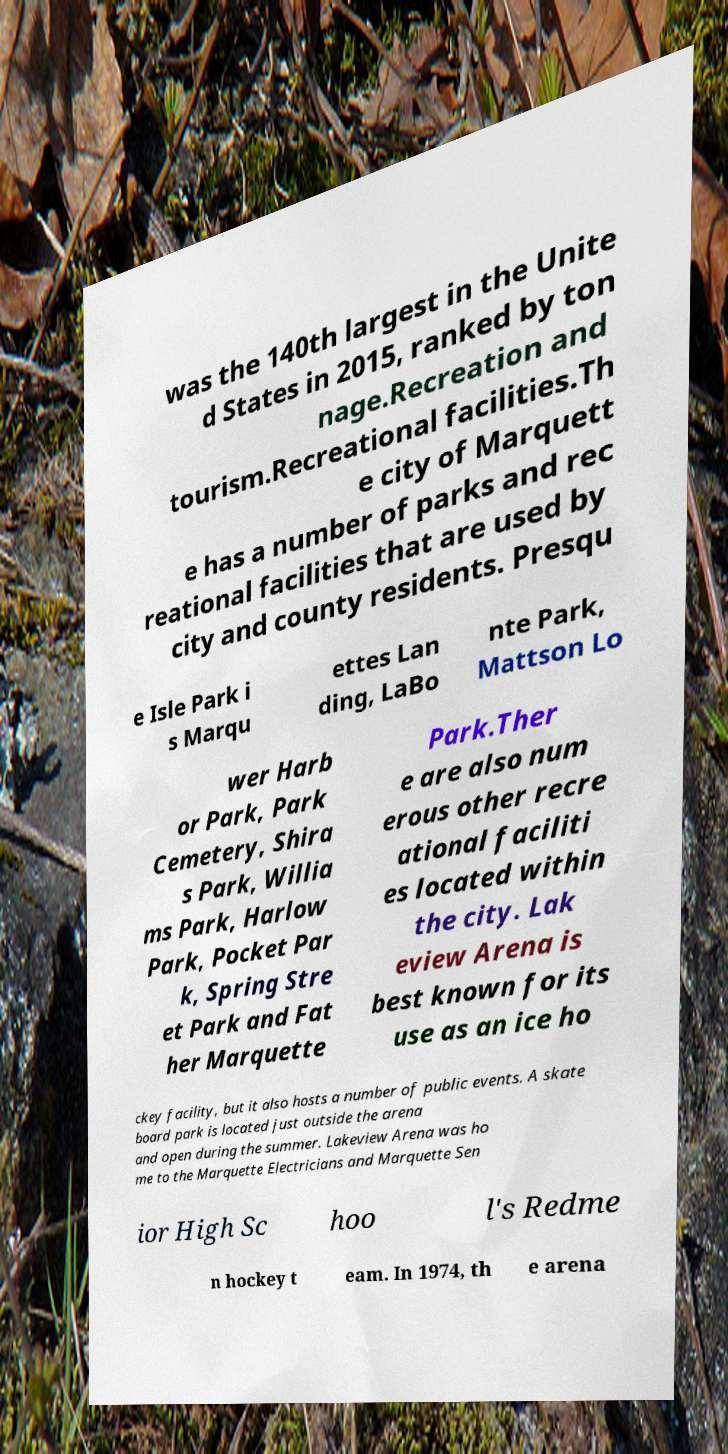I need the written content from this picture converted into text. Can you do that? was the 140th largest in the Unite d States in 2015, ranked by ton nage.Recreation and tourism.Recreational facilities.Th e city of Marquett e has a number of parks and rec reational facilities that are used by city and county residents. Presqu e Isle Park i s Marqu ettes Lan ding, LaBo nte Park, Mattson Lo wer Harb or Park, Park Cemetery, Shira s Park, Willia ms Park, Harlow Park, Pocket Par k, Spring Stre et Park and Fat her Marquette Park.Ther e are also num erous other recre ational faciliti es located within the city. Lak eview Arena is best known for its use as an ice ho ckey facility, but it also hosts a number of public events. A skate board park is located just outside the arena and open during the summer. Lakeview Arena was ho me to the Marquette Electricians and Marquette Sen ior High Sc hoo l's Redme n hockey t eam. In 1974, th e arena 